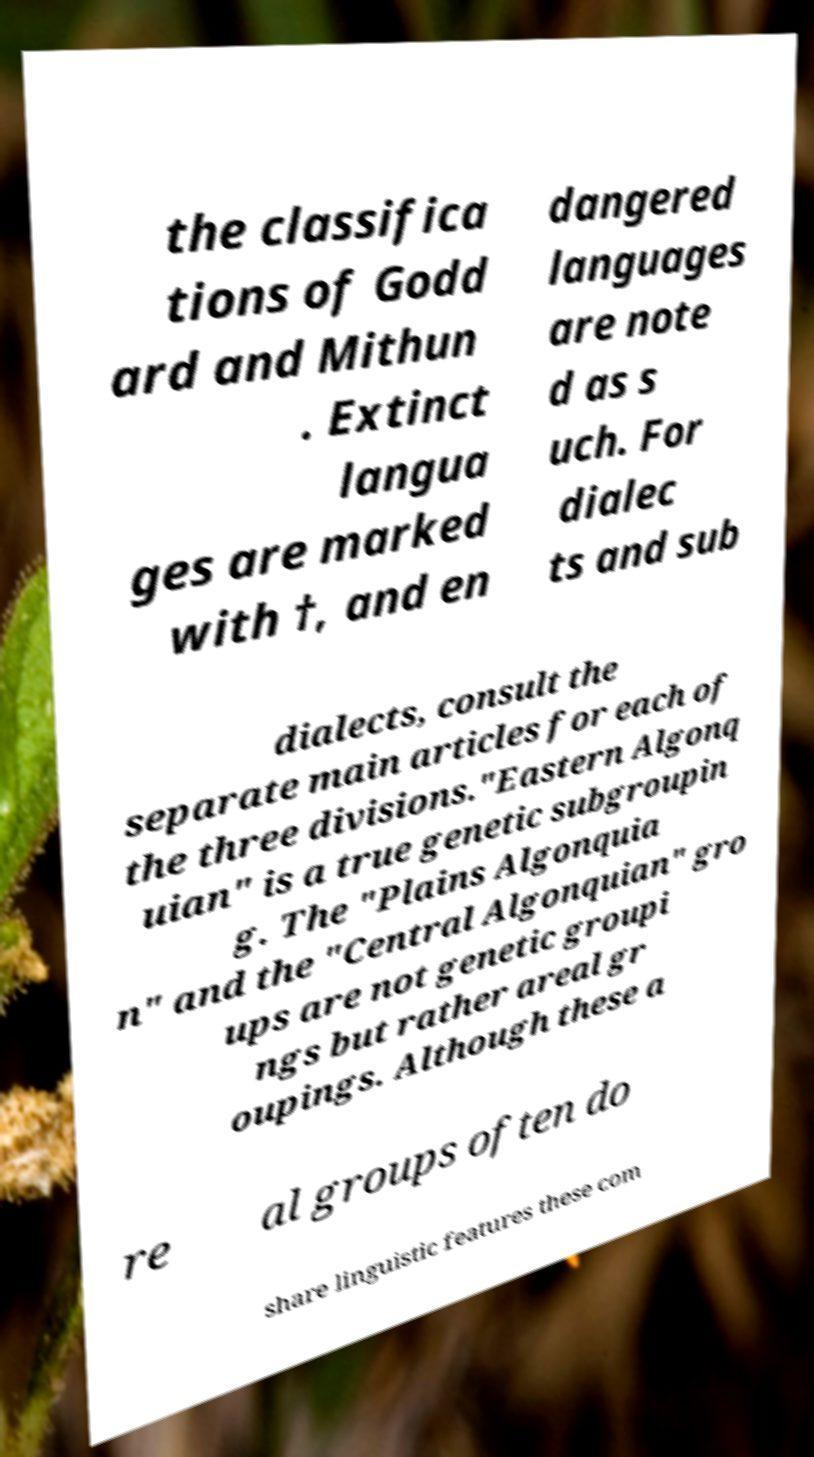Can you read and provide the text displayed in the image?This photo seems to have some interesting text. Can you extract and type it out for me? the classifica tions of Godd ard and Mithun . Extinct langua ges are marked with †, and en dangered languages are note d as s uch. For dialec ts and sub dialects, consult the separate main articles for each of the three divisions."Eastern Algonq uian" is a true genetic subgroupin g. The "Plains Algonquia n" and the "Central Algonquian" gro ups are not genetic groupi ngs but rather areal gr oupings. Although these a re al groups often do share linguistic features these com 